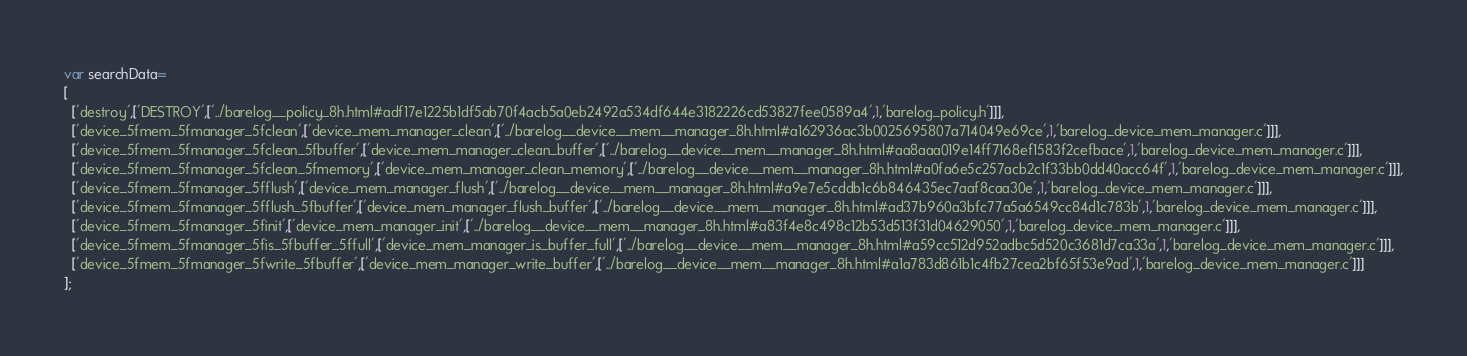Convert code to text. <code><loc_0><loc_0><loc_500><loc_500><_JavaScript_>var searchData=
[
  ['destroy',['DESTROY',['../barelog__policy_8h.html#adf17e1225b1df5ab70f4acb5a0eb2492a534df644e3182226cd53827fee0589a4',1,'barelog_policy.h']]],
  ['device_5fmem_5fmanager_5fclean',['device_mem_manager_clean',['../barelog__device__mem__manager_8h.html#a162936ac3b0025695807a714049e69ce',1,'barelog_device_mem_manager.c']]],
  ['device_5fmem_5fmanager_5fclean_5fbuffer',['device_mem_manager_clean_buffer',['../barelog__device__mem__manager_8h.html#aa8aaa019e14ff7168ef1583f2cefbace',1,'barelog_device_mem_manager.c']]],
  ['device_5fmem_5fmanager_5fclean_5fmemory',['device_mem_manager_clean_memory',['../barelog__device__mem__manager_8h.html#a0fa6e5c257acb2c1f33bb0dd40acc64f',1,'barelog_device_mem_manager.c']]],
  ['device_5fmem_5fmanager_5fflush',['device_mem_manager_flush',['../barelog__device__mem__manager_8h.html#a9e7e5cddb1c6b846435ec7aaf8caa30e',1,'barelog_device_mem_manager.c']]],
  ['device_5fmem_5fmanager_5fflush_5fbuffer',['device_mem_manager_flush_buffer',['../barelog__device__mem__manager_8h.html#ad37b960a3bfc77a5a6549cc84d1c783b',1,'barelog_device_mem_manager.c']]],
  ['device_5fmem_5fmanager_5finit',['device_mem_manager_init',['../barelog__device__mem__manager_8h.html#a83f4e8c498c12b53d513f31d04629050',1,'barelog_device_mem_manager.c']]],
  ['device_5fmem_5fmanager_5fis_5fbuffer_5ffull',['device_mem_manager_is_buffer_full',['../barelog__device__mem__manager_8h.html#a59cc512d952adbc5d520c3681d7ca33a',1,'barelog_device_mem_manager.c']]],
  ['device_5fmem_5fmanager_5fwrite_5fbuffer',['device_mem_manager_write_buffer',['../barelog__device__mem__manager_8h.html#a1a783d861b1c4fb27cea2bf65f53e9ad',1,'barelog_device_mem_manager.c']]]
];
</code> 